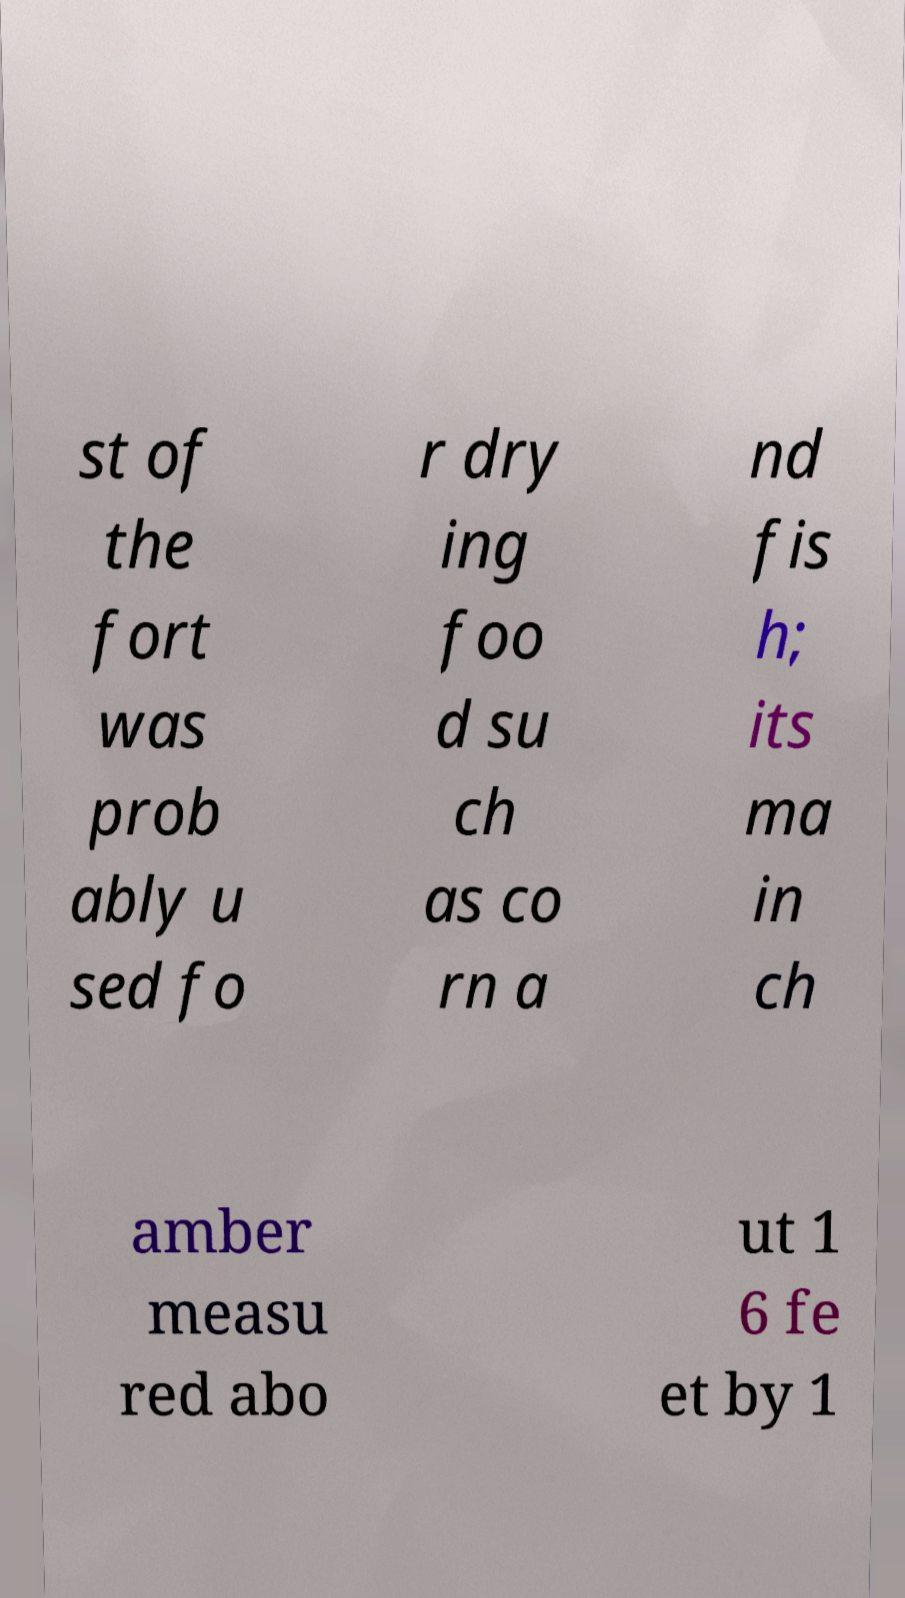I need the written content from this picture converted into text. Can you do that? st of the fort was prob ably u sed fo r dry ing foo d su ch as co rn a nd fis h; its ma in ch amber measu red abo ut 1 6 fe et by 1 